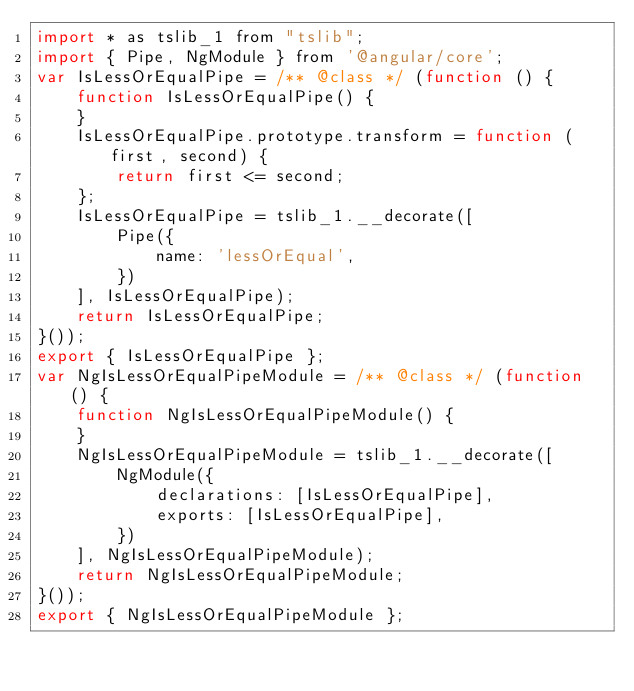<code> <loc_0><loc_0><loc_500><loc_500><_JavaScript_>import * as tslib_1 from "tslib";
import { Pipe, NgModule } from '@angular/core';
var IsLessOrEqualPipe = /** @class */ (function () {
    function IsLessOrEqualPipe() {
    }
    IsLessOrEqualPipe.prototype.transform = function (first, second) {
        return first <= second;
    };
    IsLessOrEqualPipe = tslib_1.__decorate([
        Pipe({
            name: 'lessOrEqual',
        })
    ], IsLessOrEqualPipe);
    return IsLessOrEqualPipe;
}());
export { IsLessOrEqualPipe };
var NgIsLessOrEqualPipeModule = /** @class */ (function () {
    function NgIsLessOrEqualPipeModule() {
    }
    NgIsLessOrEqualPipeModule = tslib_1.__decorate([
        NgModule({
            declarations: [IsLessOrEqualPipe],
            exports: [IsLessOrEqualPipe],
        })
    ], NgIsLessOrEqualPipeModule);
    return NgIsLessOrEqualPipeModule;
}());
export { NgIsLessOrEqualPipeModule };</code> 